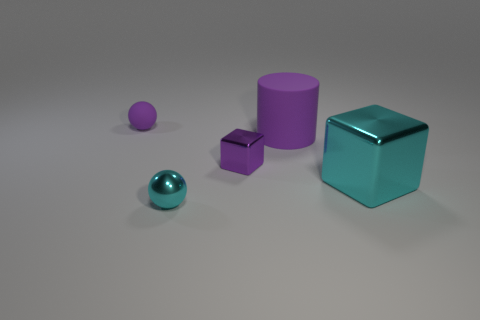Are there any big metal objects of the same color as the tiny cube?
Provide a short and direct response. No. There is a cyan metal thing that is left of the shiny object that is on the right side of the purple rubber object that is in front of the small matte sphere; how big is it?
Ensure brevity in your answer.  Small. The large metallic object is what shape?
Keep it short and to the point. Cube. What is the size of the metal thing that is the same color as the cylinder?
Provide a short and direct response. Small. How many large cyan metal blocks are to the left of the purple thing that is left of the small cyan sphere?
Give a very brief answer. 0. What number of other things are made of the same material as the purple cylinder?
Provide a succinct answer. 1. Does the ball that is left of the tiny cyan metal thing have the same material as the cyan object that is to the left of the tiny purple cube?
Ensure brevity in your answer.  No. Is there anything else that has the same shape as the big purple thing?
Make the answer very short. No. Is the cylinder made of the same material as the small purple thing to the left of the cyan metal ball?
Your response must be concise. Yes. The tiny metallic thing behind the metal block that is in front of the tiny purple thing in front of the matte sphere is what color?
Your answer should be compact. Purple. 